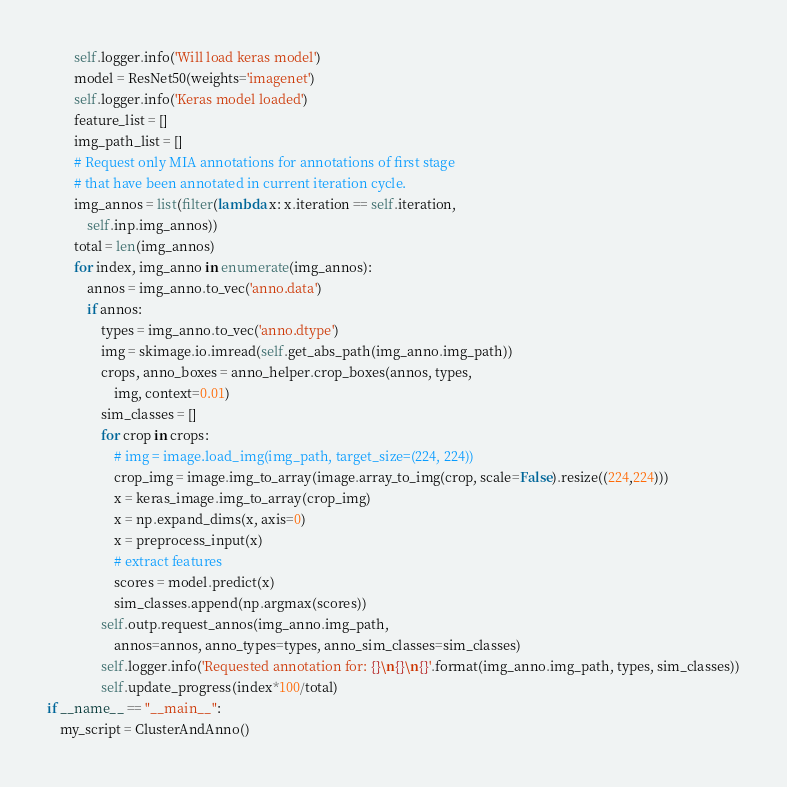Convert code to text. <code><loc_0><loc_0><loc_500><loc_500><_Python_>        self.logger.info('Will load keras model')
        model = ResNet50(weights='imagenet')
        self.logger.info('Keras model loaded')
        feature_list = []
        img_path_list = []
        # Request only MIA annotations for annotations of first stage
        # that have been annotated in current iteration cycle.
        img_annos = list(filter(lambda x: x.iteration == self.iteration, 
            self.inp.img_annos))
        total = len(img_annos)
        for index, img_anno in enumerate(img_annos):
            annos = img_anno.to_vec('anno.data')
            if annos:
                types = img_anno.to_vec('anno.dtype')
                img = skimage.io.imread(self.get_abs_path(img_anno.img_path))
                crops, anno_boxes = anno_helper.crop_boxes(annos, types, 
                    img, context=0.01)
                sim_classes = []
                for crop in crops:
                    # img = image.load_img(img_path, target_size=(224, 224))
                    crop_img = image.img_to_array(image.array_to_img(crop, scale=False).resize((224,224)))
                    x = keras_image.img_to_array(crop_img)
                    x = np.expand_dims(x, axis=0)
                    x = preprocess_input(x)
                    # extract features
                    scores = model.predict(x)
                    sim_classes.append(np.argmax(scores))
                self.outp.request_annos(img_anno.img_path, 
                    annos=annos, anno_types=types, anno_sim_classes=sim_classes)
                self.logger.info('Requested annotation for: {}\n{}\n{}'.format(img_anno.img_path, types, sim_classes))
                self.update_progress(index*100/total)
if __name__ == "__main__":
    my_script = ClusterAndAnno()
</code> 